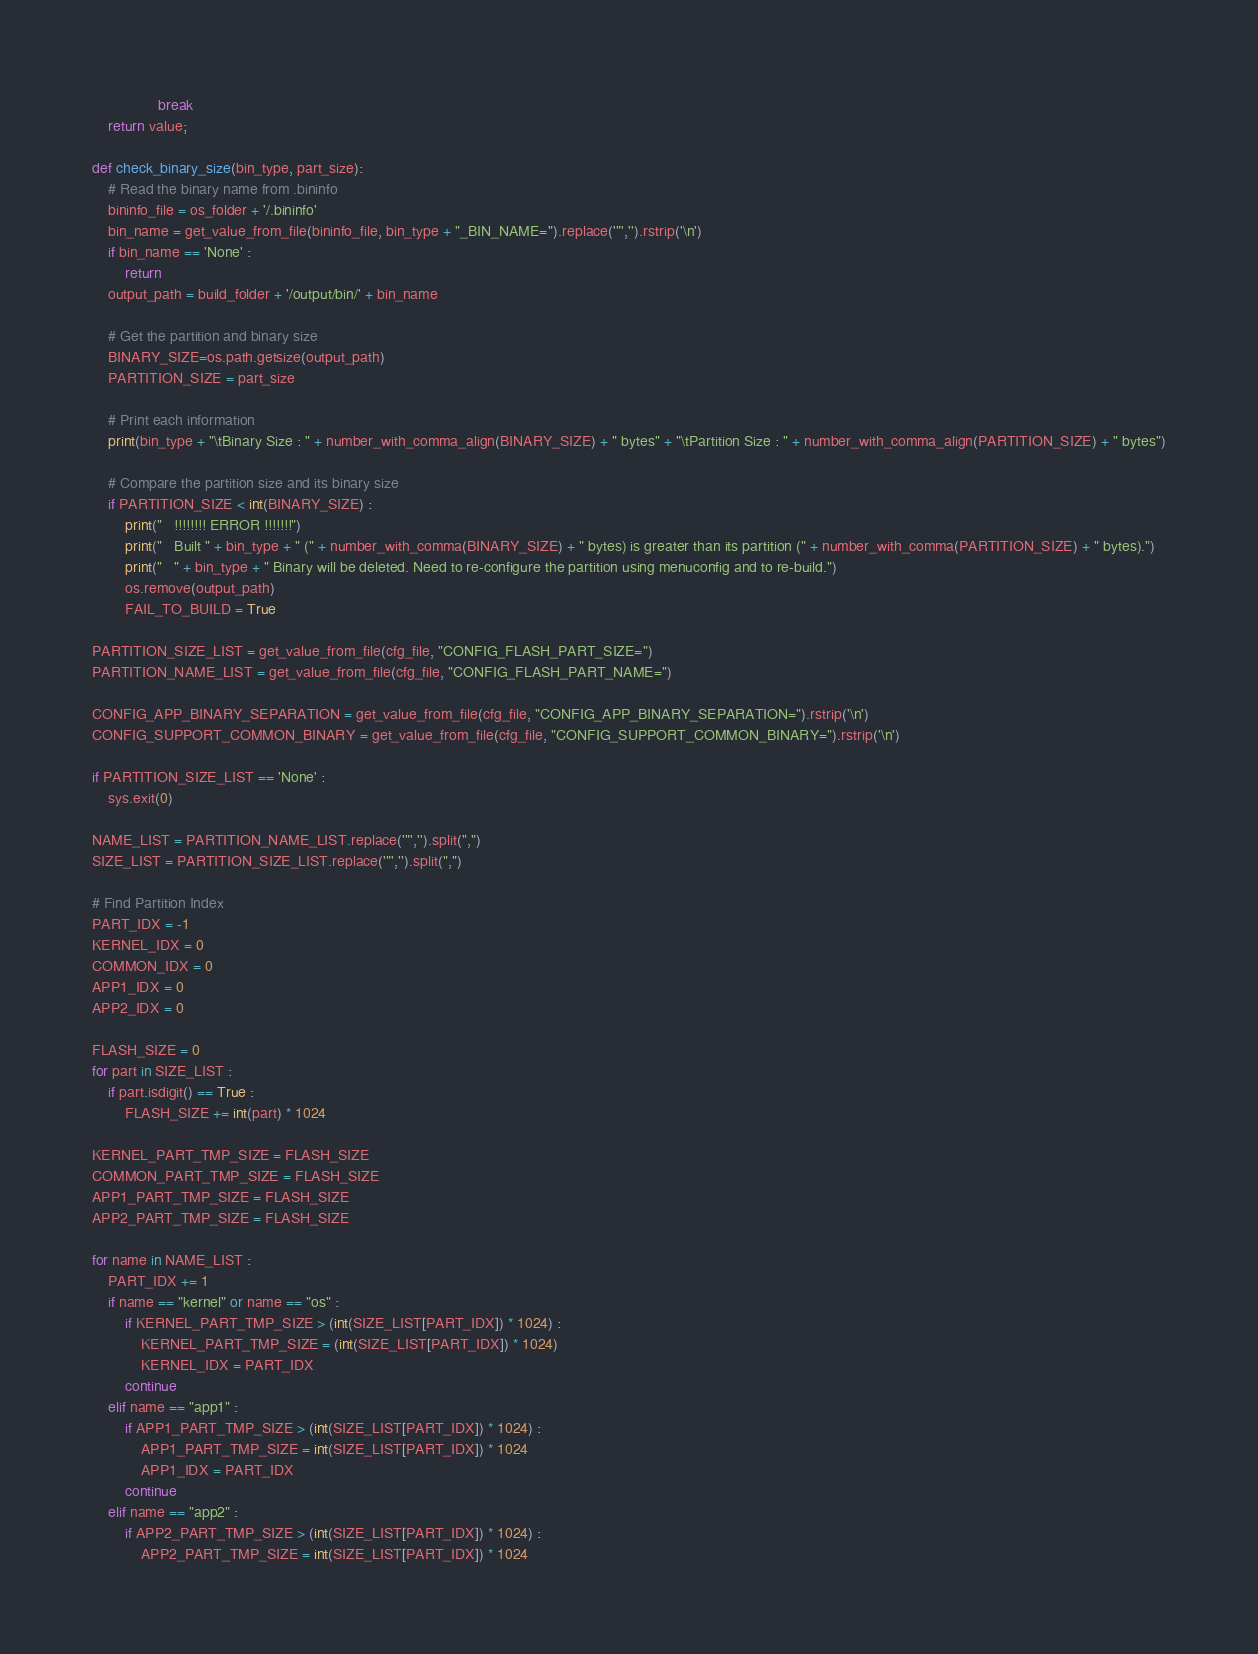<code> <loc_0><loc_0><loc_500><loc_500><_Python_>				break
	return value;

def check_binary_size(bin_type, part_size):
	# Read the binary name from .bininfo
	bininfo_file = os_folder + '/.bininfo'
	bin_name = get_value_from_file(bininfo_file, bin_type + "_BIN_NAME=").replace('"','').rstrip('\n')
	if bin_name == 'None' :
		return
	output_path = build_folder + '/output/bin/' + bin_name

	# Get the partition and binary size
	BINARY_SIZE=os.path.getsize(output_path)
	PARTITION_SIZE = part_size

	# Print each information
	print(bin_type + "\tBinary Size : " + number_with_comma_align(BINARY_SIZE) + " bytes" + "\tPartition Size : " + number_with_comma_align(PARTITION_SIZE) + " bytes")

	# Compare the partition size and its binary size
	if PARTITION_SIZE < int(BINARY_SIZE) :
		print("   !!!!!!!! ERROR !!!!!!!")
		print("   Built " + bin_type + " (" + number_with_comma(BINARY_SIZE) + " bytes) is greater than its partition (" + number_with_comma(PARTITION_SIZE) + " bytes).")
		print("   " + bin_type + " Binary will be deleted. Need to re-configure the partition using menuconfig and to re-build.")
		os.remove(output_path)
		FAIL_TO_BUILD = True

PARTITION_SIZE_LIST = get_value_from_file(cfg_file, "CONFIG_FLASH_PART_SIZE=")
PARTITION_NAME_LIST = get_value_from_file(cfg_file, "CONFIG_FLASH_PART_NAME=")

CONFIG_APP_BINARY_SEPARATION = get_value_from_file(cfg_file, "CONFIG_APP_BINARY_SEPARATION=").rstrip('\n')
CONFIG_SUPPORT_COMMON_BINARY = get_value_from_file(cfg_file, "CONFIG_SUPPORT_COMMON_BINARY=").rstrip('\n')

if PARTITION_SIZE_LIST == 'None' :
	sys.exit(0)

NAME_LIST = PARTITION_NAME_LIST.replace('"','').split(",")
SIZE_LIST = PARTITION_SIZE_LIST.replace('"','').split(",")

# Find Partition Index
PART_IDX = -1
KERNEL_IDX = 0
COMMON_IDX = 0
APP1_IDX = 0
APP2_IDX = 0

FLASH_SIZE = 0
for part in SIZE_LIST :
	if part.isdigit() == True :
		FLASH_SIZE += int(part) * 1024

KERNEL_PART_TMP_SIZE = FLASH_SIZE
COMMON_PART_TMP_SIZE = FLASH_SIZE
APP1_PART_TMP_SIZE = FLASH_SIZE
APP2_PART_TMP_SIZE = FLASH_SIZE

for name in NAME_LIST :
	PART_IDX += 1
	if name == "kernel" or name == "os" :
		if KERNEL_PART_TMP_SIZE > (int(SIZE_LIST[PART_IDX]) * 1024) :
			KERNEL_PART_TMP_SIZE = (int(SIZE_LIST[PART_IDX]) * 1024)
			KERNEL_IDX = PART_IDX
		continue
	elif name == "app1" :
		if APP1_PART_TMP_SIZE > (int(SIZE_LIST[PART_IDX]) * 1024) :
			APP1_PART_TMP_SIZE = int(SIZE_LIST[PART_IDX]) * 1024
			APP1_IDX = PART_IDX
		continue
	elif name == "app2" :
		if APP2_PART_TMP_SIZE > (int(SIZE_LIST[PART_IDX]) * 1024) :
			APP2_PART_TMP_SIZE = int(SIZE_LIST[PART_IDX]) * 1024</code> 